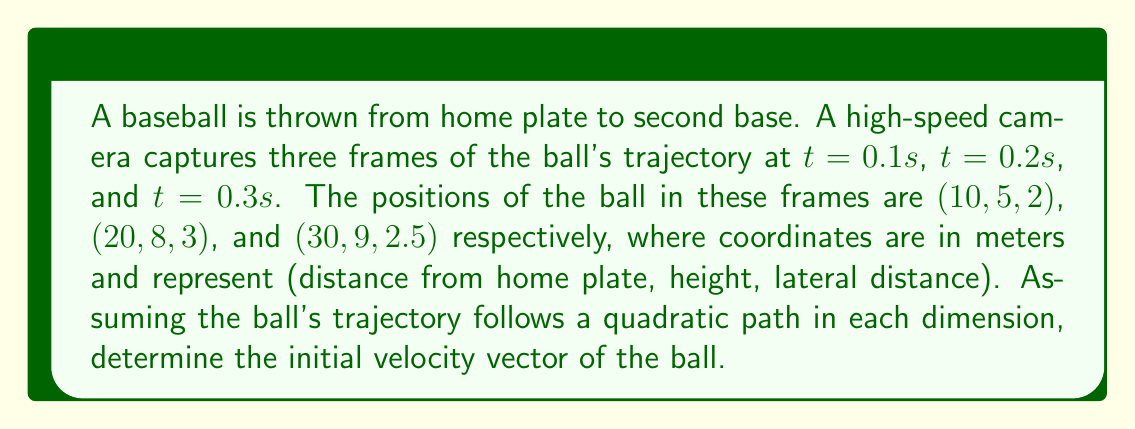Can you answer this question? Let's approach this step-by-step:

1) For each dimension (x, y, z), we can model the position as a quadratic function of time:
   $$x(t) = ax_2t^2 + ax_1t + ax_0$$
   $$y(t) = ay_2t^2 + ay_1t + ay_0$$
   $$z(t) = az_2t^2 + az_1t + az_0$$

2) We have three data points for each dimension. Let's focus on x first:
   $$10 = ax_2(0.1)^2 + ax_1(0.1) + ax_0$$
   $$20 = ax_2(0.2)^2 + ax_1(0.2) + ax_0$$
   $$30 = ax_2(0.3)^2 + ax_1(0.3) + ax_0$$

3) Solving this system of equations (you can use matrix methods or substitution), we get:
   $$ax_2 = 0, ax_1 = 100, ax_0 = 0$$

4) Repeat the process for y and z dimensions:
   For y: $$ay_2 = -150, ay_1 = 45, ay_0 = 0$$
   For z: $$az_2 = -25, az_1 = 15, az_0 = 0$$

5) The initial velocity is the first derivative of the position function at t=0:
   $$v_x(0) = ax_1 = 100$$
   $$v_y(0) = ay_1 = 45$$
   $$v_z(0) = az_1 = 15$$

6) Therefore, the initial velocity vector is (100, 45, 15) m/s.
Answer: (100, 45, 15) m/s 